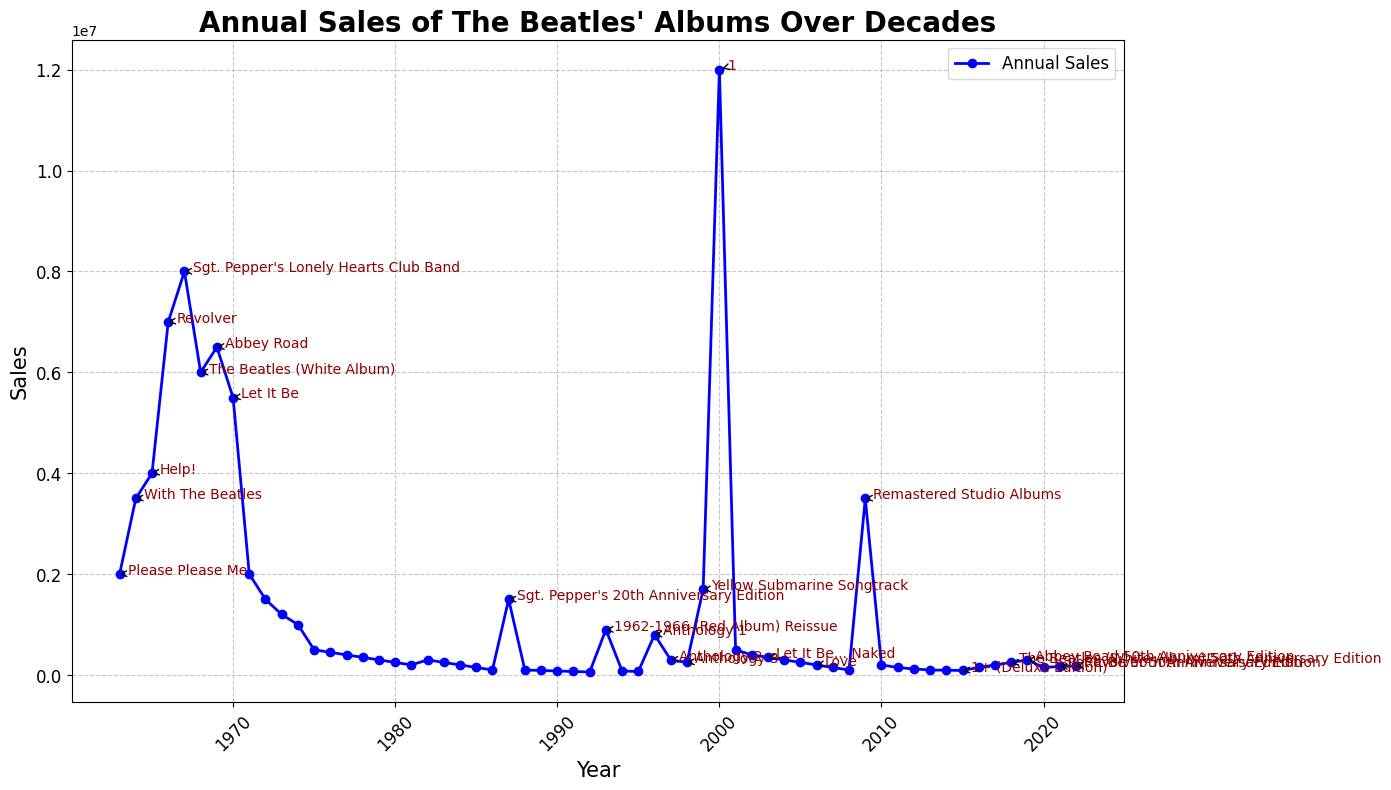which album release marked the peak in annual sales? Look for the highest point on the line chart. This is marked by the annual sales value and often highlighted with an annotation for major releases. The peak in sales is for the album "1" released in 2000.
Answer: 1 which album saw the largest increase in annual sales compared to its predecessor? Compare the sales values of each major release to its predecessor. Calculate the difference for each pair and identify the maximum. The largest increase is from the "Help!" release in 1965 to the "Revolver" release in 1966 (7000000-4000000=3000000).
Answer: Revolver how do the sales of "Let It Be 50th Anniversary Edition" compare to "Revolver 50th Anniversary Edition"? Look at the sales values annotated with "Let It Be 50th Anniversary Edition" and "Revolver 50th Anniversary Edition" in the chart. The sales are 170000 for "Let It Be 50th Anniversary Edition" and 180000 for "Revolver 50th Anniversary Edition". Compare these two values.
Answer: Revolver 50th Anniversary Edition had higher sales by 10000 during which decade did The Beatles experience the highest overall album sales? Identify individual sales for each year, sum them up for each decade: The 1960s, 1970s, 1980s, 1990s, 2000s, 2010s, and 2020s. The 1960s have the highest combined sales (46000000).
Answer: 1960s what is the difference in sales between "Sgt. Pepper's Lonely Hearts Club Band" and its 20th anniversary edition release? Look at the sales values for the original release in 1967 (8000000) and the 20th-anniversary edition in 1987 (1500000). Calculate the difference (8000000-1500000=6500000).
Answer: 6500000 which anniversary edition album had the highest sales? Among the anniversary editions annotated in the chart, identify the one with the highest sales. The anniversary editions include "Sgt. Pepper's 20th Anniversary Edition", "The Beatles (White Album) 50th Anniversary Edition", "Abbey Road 50th Anniversary Edition", "Let It Be 50th Anniversary Edition", and "Revolver 50th Anniversary Edition". "The Beatles (White Album) 50th Anniversary Edition" has the highest sales (250000).
Answer: The Beatles (White Album) 50th Anniversary Edition how did the sales trend change after The Beatles' breakup in 1970? Observe the overall trend of the line chart starting from 1971. The trend shows a significant decline in annual sales after the breakup, with occasional bumps during major re-releases.
Answer: decline with occasional bumps 